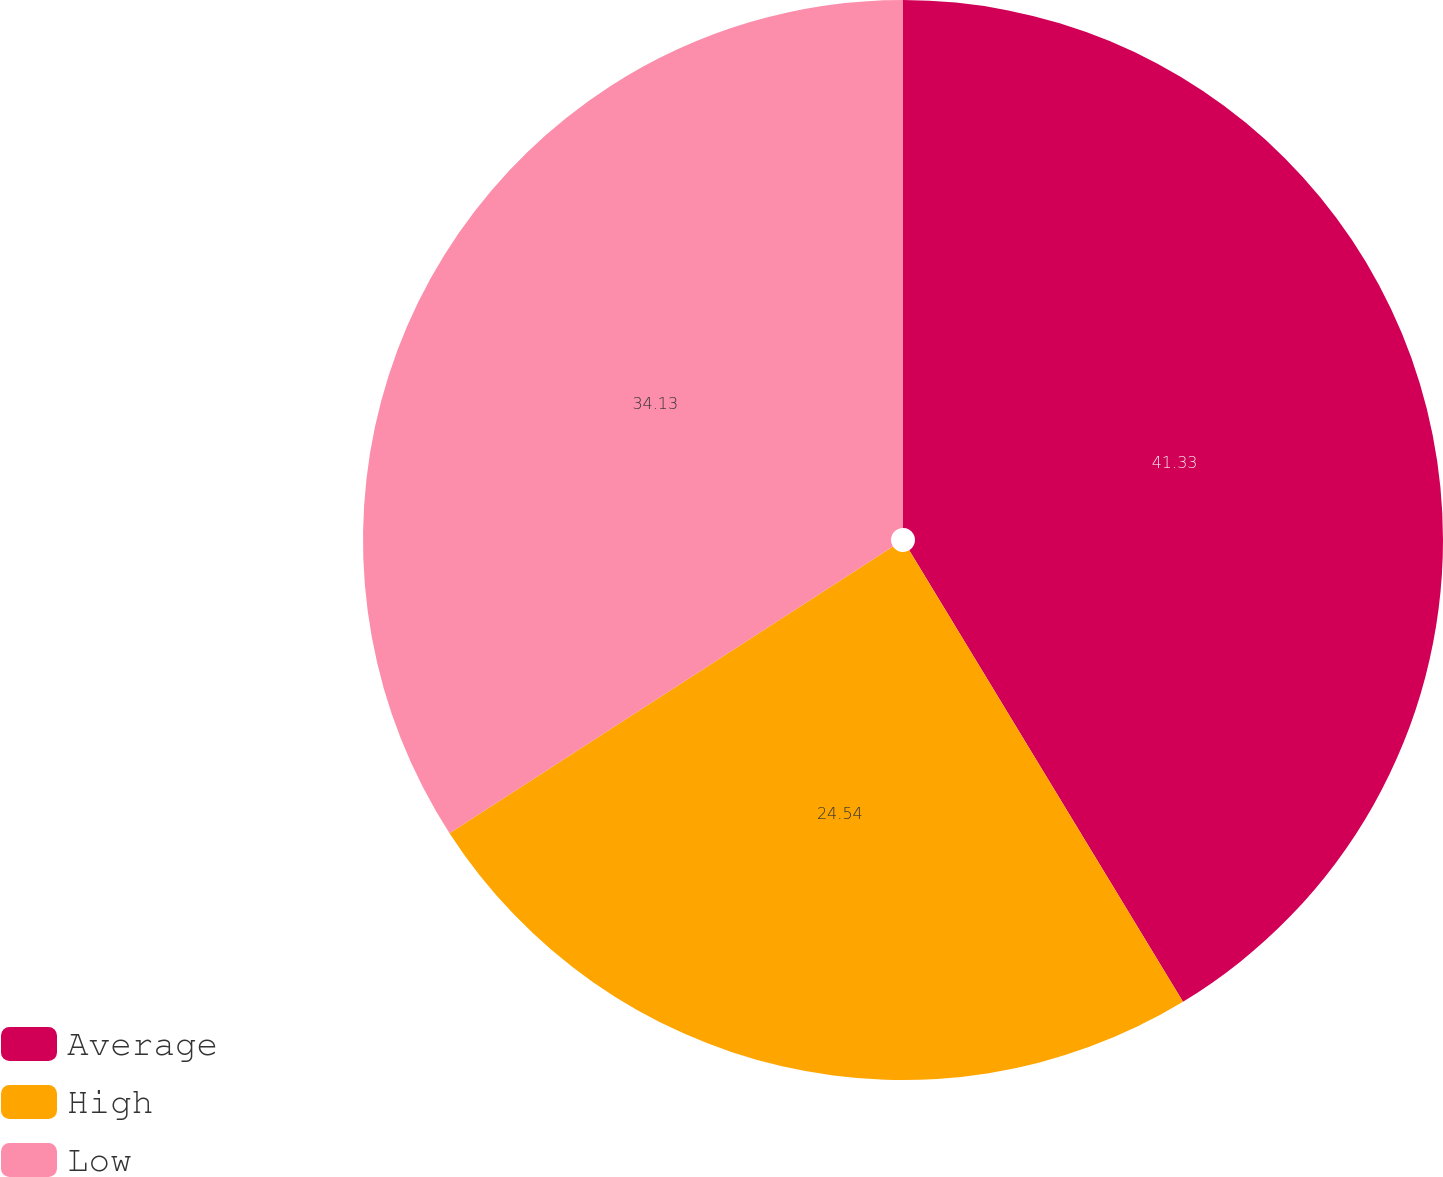Convert chart. <chart><loc_0><loc_0><loc_500><loc_500><pie_chart><fcel>Average<fcel>High<fcel>Low<nl><fcel>41.32%<fcel>24.54%<fcel>34.13%<nl></chart> 